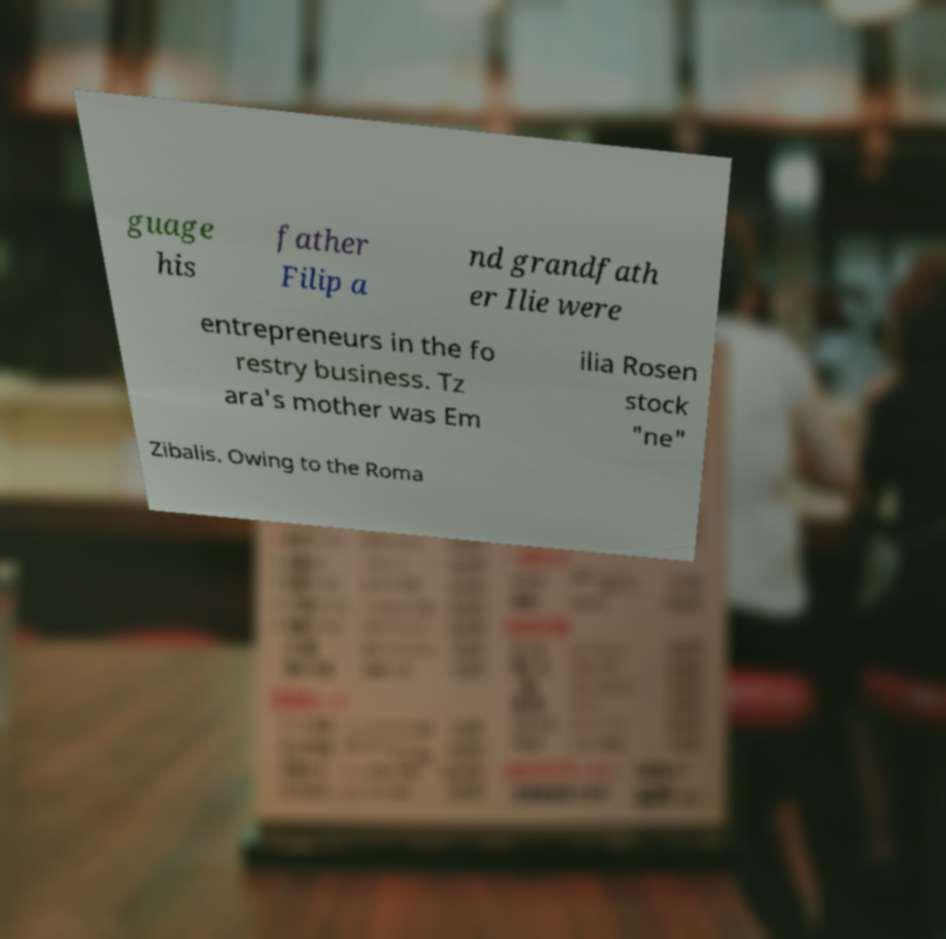Can you read and provide the text displayed in the image?This photo seems to have some interesting text. Can you extract and type it out for me? guage his father Filip a nd grandfath er Ilie were entrepreneurs in the fo restry business. Tz ara's mother was Em ilia Rosen stock "ne" Zibalis. Owing to the Roma 